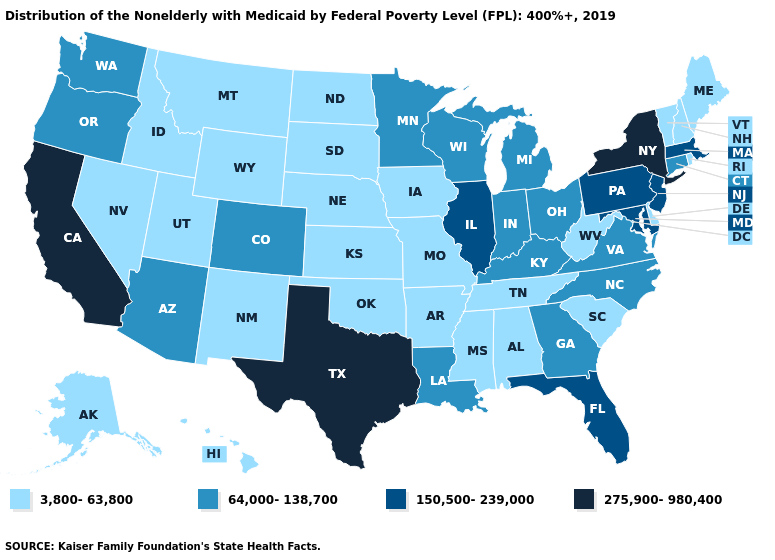Does Hawaii have a higher value than Minnesota?
Be succinct. No. Does Texas have the highest value in the USA?
Give a very brief answer. Yes. What is the value of North Dakota?
Concise answer only. 3,800-63,800. What is the value of Oklahoma?
Quick response, please. 3,800-63,800. Does Montana have the lowest value in the USA?
Be succinct. Yes. What is the value of New Hampshire?
Concise answer only. 3,800-63,800. What is the value of Texas?
Keep it brief. 275,900-980,400. Does Maryland have the highest value in the South?
Write a very short answer. No. Name the states that have a value in the range 275,900-980,400?
Be succinct. California, New York, Texas. Does the map have missing data?
Answer briefly. No. Does Delaware have the same value as North Dakota?
Be succinct. Yes. What is the value of Washington?
Short answer required. 64,000-138,700. Among the states that border North Dakota , does Minnesota have the highest value?
Concise answer only. Yes. What is the highest value in the USA?
Be succinct. 275,900-980,400. Name the states that have a value in the range 150,500-239,000?
Quick response, please. Florida, Illinois, Maryland, Massachusetts, New Jersey, Pennsylvania. 